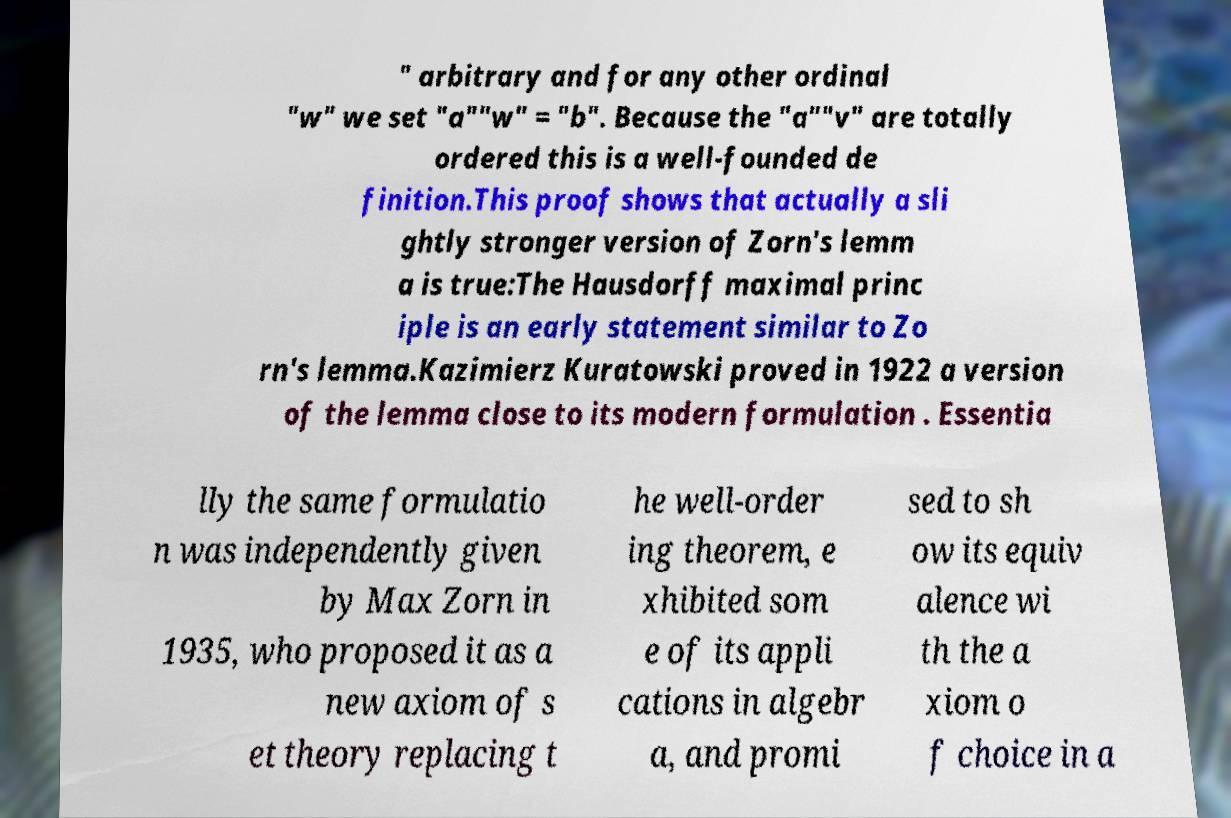Could you extract and type out the text from this image? " arbitrary and for any other ordinal "w" we set "a""w" = "b". Because the "a""v" are totally ordered this is a well-founded de finition.This proof shows that actually a sli ghtly stronger version of Zorn's lemm a is true:The Hausdorff maximal princ iple is an early statement similar to Zo rn's lemma.Kazimierz Kuratowski proved in 1922 a version of the lemma close to its modern formulation . Essentia lly the same formulatio n was independently given by Max Zorn in 1935, who proposed it as a new axiom of s et theory replacing t he well-order ing theorem, e xhibited som e of its appli cations in algebr a, and promi sed to sh ow its equiv alence wi th the a xiom o f choice in a 